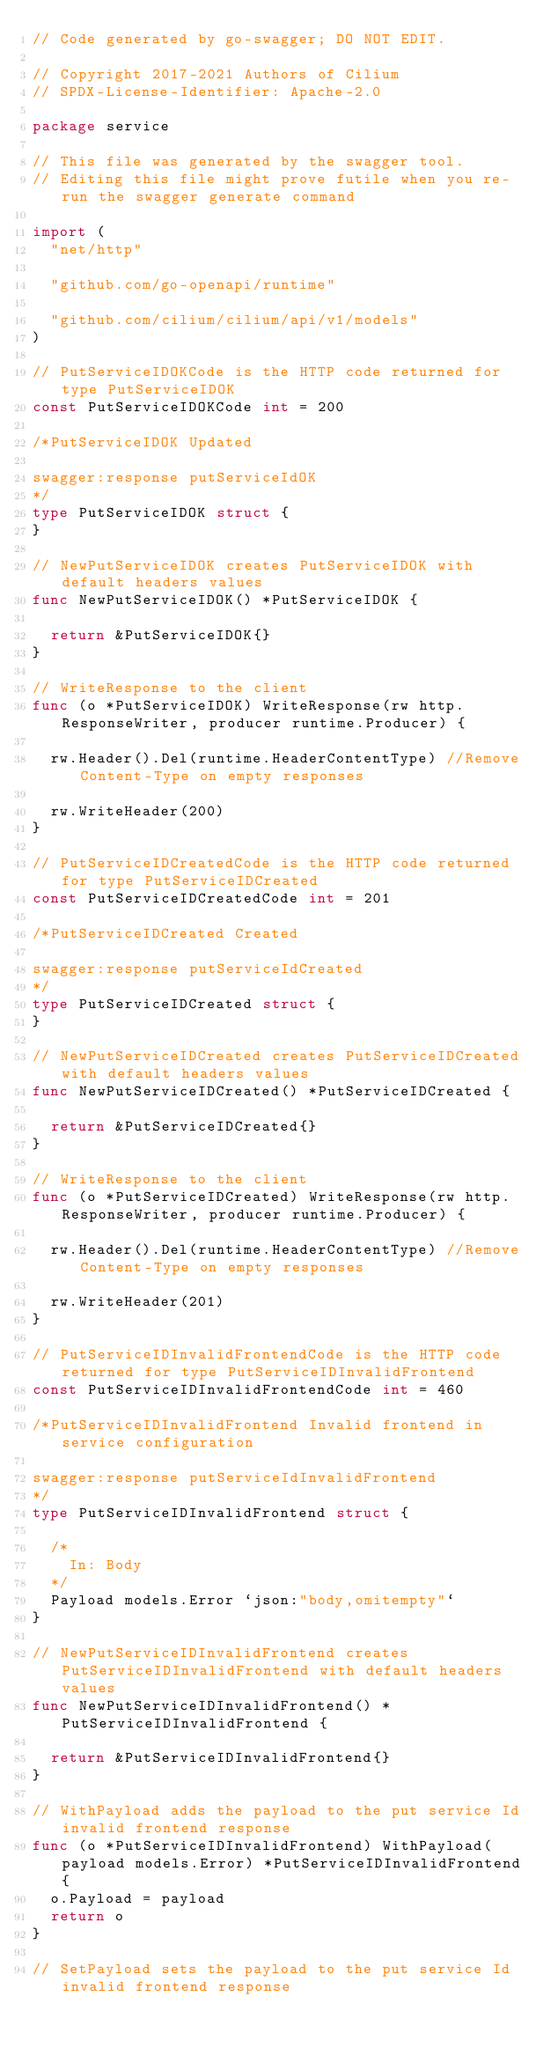Convert code to text. <code><loc_0><loc_0><loc_500><loc_500><_Go_>// Code generated by go-swagger; DO NOT EDIT.

// Copyright 2017-2021 Authors of Cilium
// SPDX-License-Identifier: Apache-2.0

package service

// This file was generated by the swagger tool.
// Editing this file might prove futile when you re-run the swagger generate command

import (
	"net/http"

	"github.com/go-openapi/runtime"

	"github.com/cilium/cilium/api/v1/models"
)

// PutServiceIDOKCode is the HTTP code returned for type PutServiceIDOK
const PutServiceIDOKCode int = 200

/*PutServiceIDOK Updated

swagger:response putServiceIdOK
*/
type PutServiceIDOK struct {
}

// NewPutServiceIDOK creates PutServiceIDOK with default headers values
func NewPutServiceIDOK() *PutServiceIDOK {

	return &PutServiceIDOK{}
}

// WriteResponse to the client
func (o *PutServiceIDOK) WriteResponse(rw http.ResponseWriter, producer runtime.Producer) {

	rw.Header().Del(runtime.HeaderContentType) //Remove Content-Type on empty responses

	rw.WriteHeader(200)
}

// PutServiceIDCreatedCode is the HTTP code returned for type PutServiceIDCreated
const PutServiceIDCreatedCode int = 201

/*PutServiceIDCreated Created

swagger:response putServiceIdCreated
*/
type PutServiceIDCreated struct {
}

// NewPutServiceIDCreated creates PutServiceIDCreated with default headers values
func NewPutServiceIDCreated() *PutServiceIDCreated {

	return &PutServiceIDCreated{}
}

// WriteResponse to the client
func (o *PutServiceIDCreated) WriteResponse(rw http.ResponseWriter, producer runtime.Producer) {

	rw.Header().Del(runtime.HeaderContentType) //Remove Content-Type on empty responses

	rw.WriteHeader(201)
}

// PutServiceIDInvalidFrontendCode is the HTTP code returned for type PutServiceIDInvalidFrontend
const PutServiceIDInvalidFrontendCode int = 460

/*PutServiceIDInvalidFrontend Invalid frontend in service configuration

swagger:response putServiceIdInvalidFrontend
*/
type PutServiceIDInvalidFrontend struct {

	/*
	  In: Body
	*/
	Payload models.Error `json:"body,omitempty"`
}

// NewPutServiceIDInvalidFrontend creates PutServiceIDInvalidFrontend with default headers values
func NewPutServiceIDInvalidFrontend() *PutServiceIDInvalidFrontend {

	return &PutServiceIDInvalidFrontend{}
}

// WithPayload adds the payload to the put service Id invalid frontend response
func (o *PutServiceIDInvalidFrontend) WithPayload(payload models.Error) *PutServiceIDInvalidFrontend {
	o.Payload = payload
	return o
}

// SetPayload sets the payload to the put service Id invalid frontend response</code> 